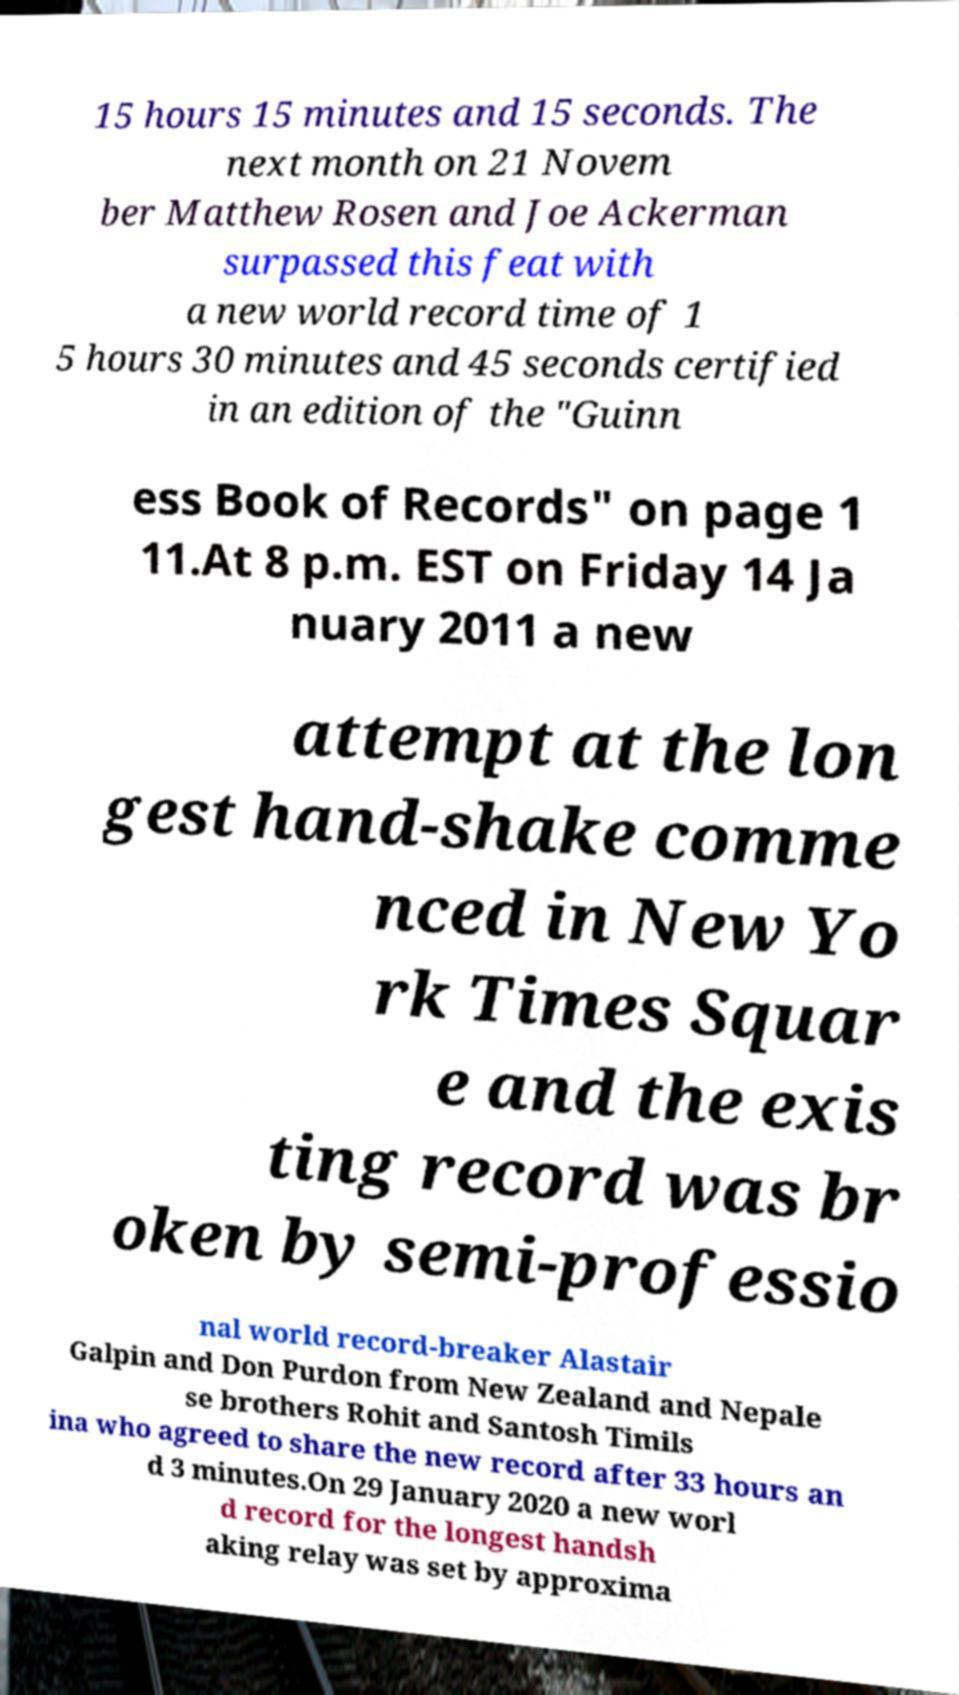Please identify and transcribe the text found in this image. 15 hours 15 minutes and 15 seconds. The next month on 21 Novem ber Matthew Rosen and Joe Ackerman surpassed this feat with a new world record time of 1 5 hours 30 minutes and 45 seconds certified in an edition of the "Guinn ess Book of Records" on page 1 11.At 8 p.m. EST on Friday 14 Ja nuary 2011 a new attempt at the lon gest hand-shake comme nced in New Yo rk Times Squar e and the exis ting record was br oken by semi-professio nal world record-breaker Alastair Galpin and Don Purdon from New Zealand and Nepale se brothers Rohit and Santosh Timils ina who agreed to share the new record after 33 hours an d 3 minutes.On 29 January 2020 a new worl d record for the longest handsh aking relay was set by approxima 